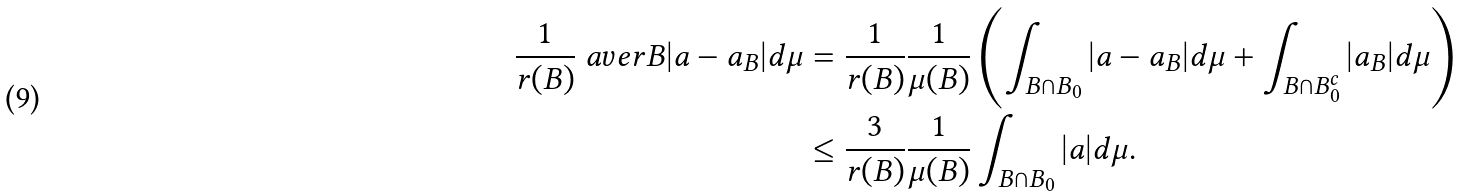<formula> <loc_0><loc_0><loc_500><loc_500>\frac { 1 } { r ( B ) } \ a v e r { B } | a - a _ { B } | d \mu & = \frac { 1 } { r ( B ) } \frac { 1 } { \mu ( B ) } \left ( \int _ { B \cap B _ { 0 } } | a - a _ { B } | d \mu + \int _ { B \cap B _ { 0 } ^ { c } } | a _ { B } | d \mu \right ) \\ & \leq \frac { 3 } { r ( B ) } \frac { 1 } { \mu ( B ) } \int _ { B \cap B _ { 0 } } | a | d \mu .</formula> 